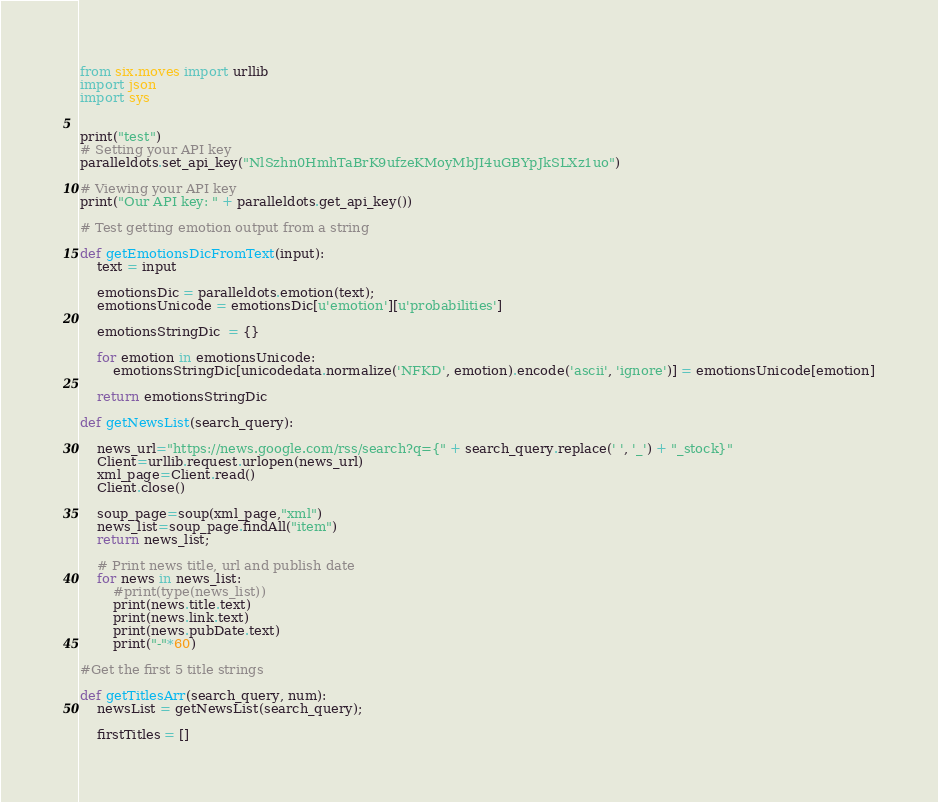<code> <loc_0><loc_0><loc_500><loc_500><_Python_>from six.moves import urllib
import json
import sys


print("test")
# Setting your API key
paralleldots.set_api_key("NlSzhn0HmhTaBrK9ufzeKMoyMbJI4uGBYpJkSLXz1uo")

# Viewing your API key
print("Our API key: " + paralleldots.get_api_key())

# Test getting emotion output from a string

def getEmotionsDicFromText(input):
    text = input

    emotionsDic = paralleldots.emotion(text);
    emotionsUnicode = emotionsDic[u'emotion'][u'probabilities']

    emotionsStringDic  = {}

    for emotion in emotionsUnicode:
        emotionsStringDic[unicodedata.normalize('NFKD', emotion).encode('ascii', 'ignore')] = emotionsUnicode[emotion]

    return emotionsStringDic

def getNewsList(search_query):

    news_url="https://news.google.com/rss/search?q={" + search_query.replace(' ', '_') + "_stock}"
    Client=urllib.request.urlopen(news_url)
    xml_page=Client.read()
    Client.close()

    soup_page=soup(xml_page,"xml")
    news_list=soup_page.findAll("item")
    return news_list;

    # Print news title, url and publish date
    for news in news_list:
        #print(type(news_list))
        print(news.title.text)
        print(news.link.text)
        print(news.pubDate.text)
        print("-"*60)

#Get the first 5 title strings

def getTitlesArr(search_query, num):
    newsList = getNewsList(search_query);

    firstTitles = []
</code> 